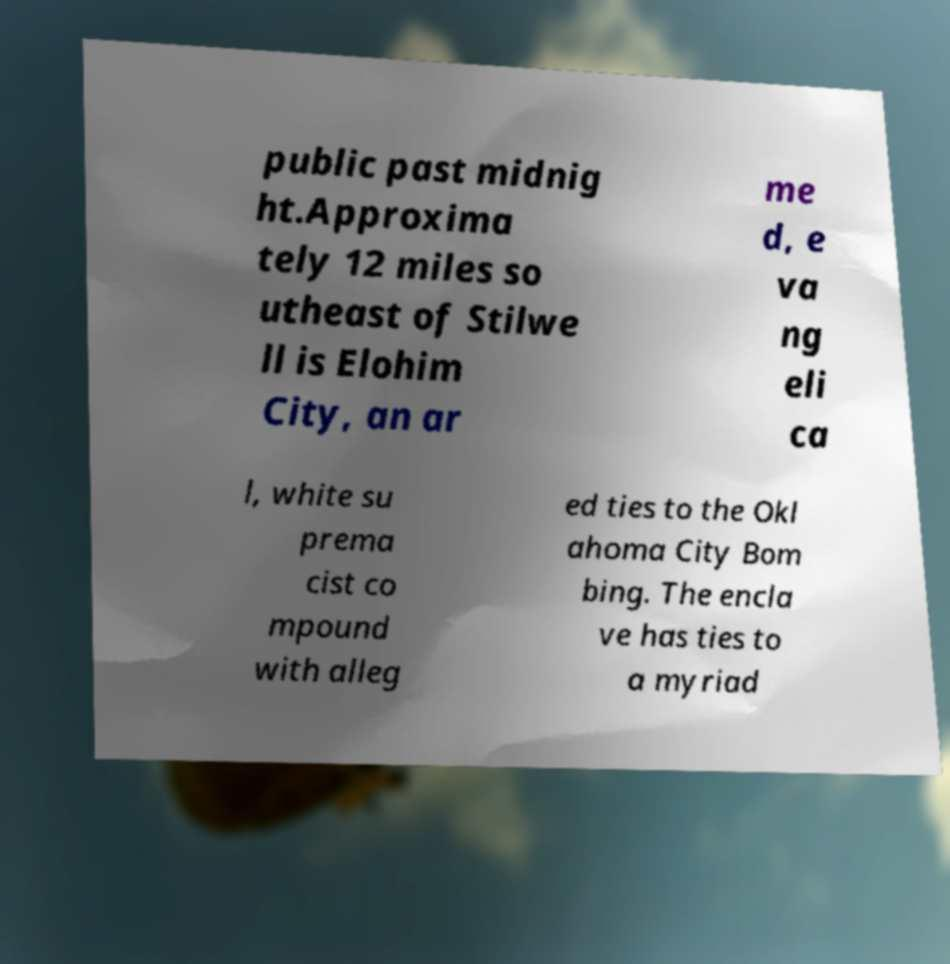I need the written content from this picture converted into text. Can you do that? public past midnig ht.Approxima tely 12 miles so utheast of Stilwe ll is Elohim City, an ar me d, e va ng eli ca l, white su prema cist co mpound with alleg ed ties to the Okl ahoma City Bom bing. The encla ve has ties to a myriad 